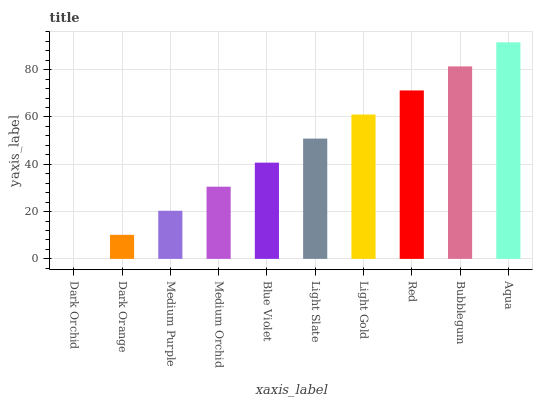Is Dark Orchid the minimum?
Answer yes or no. Yes. Is Aqua the maximum?
Answer yes or no. Yes. Is Dark Orange the minimum?
Answer yes or no. No. Is Dark Orange the maximum?
Answer yes or no. No. Is Dark Orange greater than Dark Orchid?
Answer yes or no. Yes. Is Dark Orchid less than Dark Orange?
Answer yes or no. Yes. Is Dark Orchid greater than Dark Orange?
Answer yes or no. No. Is Dark Orange less than Dark Orchid?
Answer yes or no. No. Is Light Slate the high median?
Answer yes or no. Yes. Is Blue Violet the low median?
Answer yes or no. Yes. Is Aqua the high median?
Answer yes or no. No. Is Medium Purple the low median?
Answer yes or no. No. 